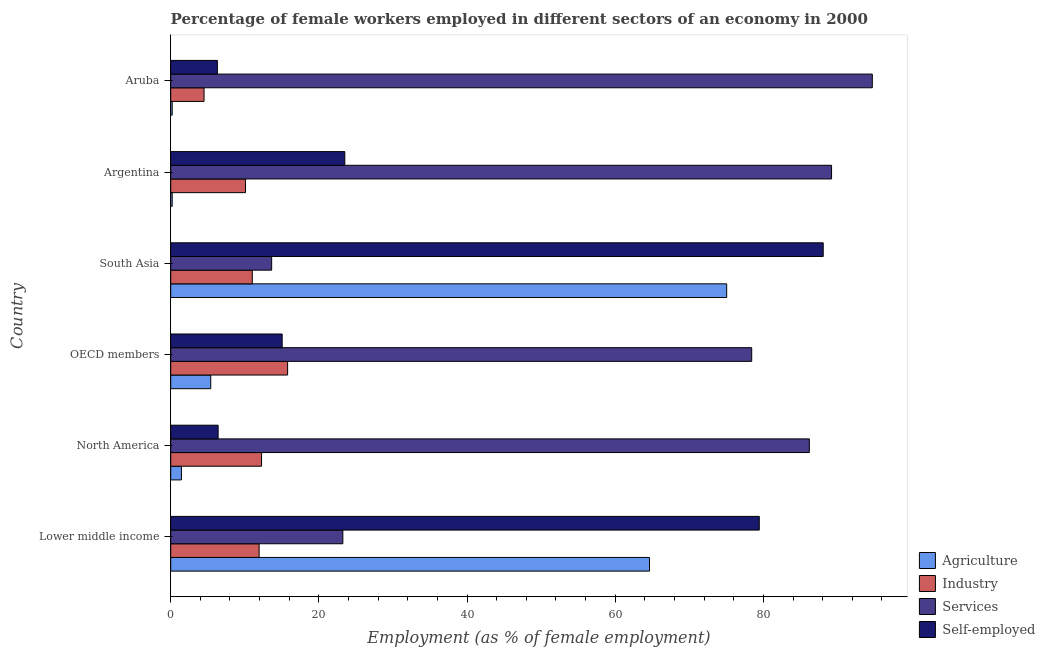How many different coloured bars are there?
Offer a very short reply. 4. Are the number of bars per tick equal to the number of legend labels?
Keep it short and to the point. Yes. Are the number of bars on each tick of the Y-axis equal?
Give a very brief answer. Yes. What is the percentage of female workers in industry in Lower middle income?
Your answer should be very brief. 11.94. Across all countries, what is the maximum percentage of female workers in industry?
Give a very brief answer. 15.78. Across all countries, what is the minimum percentage of self employed female workers?
Provide a short and direct response. 6.3. In which country was the percentage of self employed female workers maximum?
Ensure brevity in your answer.  South Asia. In which country was the percentage of female workers in industry minimum?
Offer a very short reply. Aruba. What is the total percentage of female workers in services in the graph?
Give a very brief answer. 385.38. What is the difference between the percentage of female workers in industry in Aruba and that in North America?
Give a very brief answer. -7.76. What is the difference between the percentage of female workers in industry in South Asia and the percentage of female workers in services in North America?
Offer a very short reply. -75.19. What is the average percentage of female workers in industry per country?
Give a very brief answer. 10.93. What is the difference between the percentage of female workers in services and percentage of female workers in agriculture in South Asia?
Provide a short and direct response. -61.41. What is the ratio of the percentage of self employed female workers in Aruba to that in OECD members?
Offer a very short reply. 0.42. Is the difference between the percentage of self employed female workers in Aruba and OECD members greater than the difference between the percentage of female workers in agriculture in Aruba and OECD members?
Make the answer very short. No. What is the difference between the highest and the second highest percentage of female workers in industry?
Offer a very short reply. 3.52. What is the difference between the highest and the lowest percentage of female workers in services?
Your response must be concise. 81.07. What does the 4th bar from the top in Lower middle income represents?
Provide a short and direct response. Agriculture. What does the 1st bar from the bottom in OECD members represents?
Ensure brevity in your answer.  Agriculture. Is it the case that in every country, the sum of the percentage of female workers in agriculture and percentage of female workers in industry is greater than the percentage of female workers in services?
Your answer should be compact. No. How many bars are there?
Provide a short and direct response. 24. How many countries are there in the graph?
Ensure brevity in your answer.  6. What is the difference between two consecutive major ticks on the X-axis?
Offer a very short reply. 20. Are the values on the major ticks of X-axis written in scientific E-notation?
Provide a succinct answer. No. Does the graph contain any zero values?
Keep it short and to the point. No. How many legend labels are there?
Offer a very short reply. 4. What is the title of the graph?
Offer a very short reply. Percentage of female workers employed in different sectors of an economy in 2000. What is the label or title of the X-axis?
Your answer should be very brief. Employment (as % of female employment). What is the label or title of the Y-axis?
Offer a very short reply. Country. What is the Employment (as % of female employment) of Agriculture in Lower middle income?
Your answer should be compact. 64.63. What is the Employment (as % of female employment) of Industry in Lower middle income?
Your response must be concise. 11.94. What is the Employment (as % of female employment) of Services in Lower middle income?
Offer a very short reply. 23.24. What is the Employment (as % of female employment) in Self-employed in Lower middle income?
Your answer should be compact. 79.44. What is the Employment (as % of female employment) of Agriculture in North America?
Make the answer very short. 1.45. What is the Employment (as % of female employment) of Industry in North America?
Offer a terse response. 12.26. What is the Employment (as % of female employment) in Services in North America?
Keep it short and to the point. 86.2. What is the Employment (as % of female employment) of Self-employed in North America?
Your answer should be very brief. 6.4. What is the Employment (as % of female employment) of Agriculture in OECD members?
Your response must be concise. 5.4. What is the Employment (as % of female employment) of Industry in OECD members?
Keep it short and to the point. 15.78. What is the Employment (as % of female employment) of Services in OECD members?
Provide a succinct answer. 78.42. What is the Employment (as % of female employment) of Self-employed in OECD members?
Offer a very short reply. 15.05. What is the Employment (as % of female employment) of Agriculture in South Asia?
Offer a terse response. 75.04. What is the Employment (as % of female employment) of Industry in South Asia?
Your answer should be compact. 11.01. What is the Employment (as % of female employment) in Services in South Asia?
Ensure brevity in your answer.  13.63. What is the Employment (as % of female employment) in Self-employed in South Asia?
Your response must be concise. 88.07. What is the Employment (as % of female employment) of Agriculture in Argentina?
Keep it short and to the point. 0.2. What is the Employment (as % of female employment) of Industry in Argentina?
Your response must be concise. 10.1. What is the Employment (as % of female employment) in Services in Argentina?
Provide a short and direct response. 89.2. What is the Employment (as % of female employment) of Agriculture in Aruba?
Your answer should be compact. 0.2. What is the Employment (as % of female employment) in Industry in Aruba?
Provide a succinct answer. 4.5. What is the Employment (as % of female employment) in Services in Aruba?
Give a very brief answer. 94.7. What is the Employment (as % of female employment) in Self-employed in Aruba?
Ensure brevity in your answer.  6.3. Across all countries, what is the maximum Employment (as % of female employment) of Agriculture?
Your answer should be compact. 75.04. Across all countries, what is the maximum Employment (as % of female employment) in Industry?
Provide a succinct answer. 15.78. Across all countries, what is the maximum Employment (as % of female employment) in Services?
Your answer should be very brief. 94.7. Across all countries, what is the maximum Employment (as % of female employment) in Self-employed?
Give a very brief answer. 88.07. Across all countries, what is the minimum Employment (as % of female employment) of Agriculture?
Provide a short and direct response. 0.2. Across all countries, what is the minimum Employment (as % of female employment) of Services?
Provide a short and direct response. 13.63. Across all countries, what is the minimum Employment (as % of female employment) in Self-employed?
Make the answer very short. 6.3. What is the total Employment (as % of female employment) in Agriculture in the graph?
Your answer should be very brief. 146.92. What is the total Employment (as % of female employment) in Industry in the graph?
Ensure brevity in your answer.  65.59. What is the total Employment (as % of female employment) in Services in the graph?
Ensure brevity in your answer.  385.38. What is the total Employment (as % of female employment) of Self-employed in the graph?
Ensure brevity in your answer.  218.76. What is the difference between the Employment (as % of female employment) of Agriculture in Lower middle income and that in North America?
Your answer should be very brief. 63.18. What is the difference between the Employment (as % of female employment) of Industry in Lower middle income and that in North America?
Your answer should be compact. -0.33. What is the difference between the Employment (as % of female employment) in Services in Lower middle income and that in North America?
Your answer should be very brief. -62.96. What is the difference between the Employment (as % of female employment) in Self-employed in Lower middle income and that in North America?
Offer a terse response. 73.04. What is the difference between the Employment (as % of female employment) of Agriculture in Lower middle income and that in OECD members?
Provide a short and direct response. 59.22. What is the difference between the Employment (as % of female employment) in Industry in Lower middle income and that in OECD members?
Offer a terse response. -3.84. What is the difference between the Employment (as % of female employment) of Services in Lower middle income and that in OECD members?
Give a very brief answer. -55.18. What is the difference between the Employment (as % of female employment) of Self-employed in Lower middle income and that in OECD members?
Your answer should be very brief. 64.4. What is the difference between the Employment (as % of female employment) in Agriculture in Lower middle income and that in South Asia?
Offer a terse response. -10.42. What is the difference between the Employment (as % of female employment) of Industry in Lower middle income and that in South Asia?
Your response must be concise. 0.92. What is the difference between the Employment (as % of female employment) in Services in Lower middle income and that in South Asia?
Offer a very short reply. 9.61. What is the difference between the Employment (as % of female employment) of Self-employed in Lower middle income and that in South Asia?
Provide a short and direct response. -8.63. What is the difference between the Employment (as % of female employment) in Agriculture in Lower middle income and that in Argentina?
Provide a succinct answer. 64.43. What is the difference between the Employment (as % of female employment) in Industry in Lower middle income and that in Argentina?
Your response must be concise. 1.84. What is the difference between the Employment (as % of female employment) in Services in Lower middle income and that in Argentina?
Provide a succinct answer. -65.96. What is the difference between the Employment (as % of female employment) in Self-employed in Lower middle income and that in Argentina?
Ensure brevity in your answer.  55.94. What is the difference between the Employment (as % of female employment) in Agriculture in Lower middle income and that in Aruba?
Keep it short and to the point. 64.43. What is the difference between the Employment (as % of female employment) of Industry in Lower middle income and that in Aruba?
Offer a very short reply. 7.44. What is the difference between the Employment (as % of female employment) of Services in Lower middle income and that in Aruba?
Your answer should be very brief. -71.46. What is the difference between the Employment (as % of female employment) of Self-employed in Lower middle income and that in Aruba?
Give a very brief answer. 73.14. What is the difference between the Employment (as % of female employment) of Agriculture in North America and that in OECD members?
Provide a short and direct response. -3.96. What is the difference between the Employment (as % of female employment) in Industry in North America and that in OECD members?
Ensure brevity in your answer.  -3.52. What is the difference between the Employment (as % of female employment) in Services in North America and that in OECD members?
Keep it short and to the point. 7.78. What is the difference between the Employment (as % of female employment) of Self-employed in North America and that in OECD members?
Give a very brief answer. -8.64. What is the difference between the Employment (as % of female employment) in Agriculture in North America and that in South Asia?
Ensure brevity in your answer.  -73.59. What is the difference between the Employment (as % of female employment) in Industry in North America and that in South Asia?
Provide a succinct answer. 1.25. What is the difference between the Employment (as % of female employment) of Services in North America and that in South Asia?
Your answer should be compact. 72.57. What is the difference between the Employment (as % of female employment) of Self-employed in North America and that in South Asia?
Offer a terse response. -81.67. What is the difference between the Employment (as % of female employment) in Agriculture in North America and that in Argentina?
Make the answer very short. 1.25. What is the difference between the Employment (as % of female employment) in Industry in North America and that in Argentina?
Offer a very short reply. 2.16. What is the difference between the Employment (as % of female employment) in Self-employed in North America and that in Argentina?
Offer a terse response. -17.1. What is the difference between the Employment (as % of female employment) in Agriculture in North America and that in Aruba?
Offer a very short reply. 1.25. What is the difference between the Employment (as % of female employment) in Industry in North America and that in Aruba?
Keep it short and to the point. 7.76. What is the difference between the Employment (as % of female employment) in Services in North America and that in Aruba?
Ensure brevity in your answer.  -8.5. What is the difference between the Employment (as % of female employment) of Self-employed in North America and that in Aruba?
Your answer should be very brief. 0.1. What is the difference between the Employment (as % of female employment) of Agriculture in OECD members and that in South Asia?
Your answer should be very brief. -69.64. What is the difference between the Employment (as % of female employment) in Industry in OECD members and that in South Asia?
Provide a succinct answer. 4.77. What is the difference between the Employment (as % of female employment) of Services in OECD members and that in South Asia?
Your answer should be very brief. 64.79. What is the difference between the Employment (as % of female employment) of Self-employed in OECD members and that in South Asia?
Provide a short and direct response. -73.03. What is the difference between the Employment (as % of female employment) in Agriculture in OECD members and that in Argentina?
Offer a terse response. 5.2. What is the difference between the Employment (as % of female employment) in Industry in OECD members and that in Argentina?
Ensure brevity in your answer.  5.68. What is the difference between the Employment (as % of female employment) of Services in OECD members and that in Argentina?
Keep it short and to the point. -10.78. What is the difference between the Employment (as % of female employment) in Self-employed in OECD members and that in Argentina?
Ensure brevity in your answer.  -8.45. What is the difference between the Employment (as % of female employment) in Agriculture in OECD members and that in Aruba?
Ensure brevity in your answer.  5.2. What is the difference between the Employment (as % of female employment) in Industry in OECD members and that in Aruba?
Offer a very short reply. 11.28. What is the difference between the Employment (as % of female employment) of Services in OECD members and that in Aruba?
Offer a terse response. -16.28. What is the difference between the Employment (as % of female employment) in Self-employed in OECD members and that in Aruba?
Your answer should be very brief. 8.75. What is the difference between the Employment (as % of female employment) in Agriculture in South Asia and that in Argentina?
Your answer should be compact. 74.84. What is the difference between the Employment (as % of female employment) of Industry in South Asia and that in Argentina?
Offer a very short reply. 0.91. What is the difference between the Employment (as % of female employment) in Services in South Asia and that in Argentina?
Keep it short and to the point. -75.57. What is the difference between the Employment (as % of female employment) in Self-employed in South Asia and that in Argentina?
Provide a short and direct response. 64.57. What is the difference between the Employment (as % of female employment) in Agriculture in South Asia and that in Aruba?
Provide a succinct answer. 74.84. What is the difference between the Employment (as % of female employment) of Industry in South Asia and that in Aruba?
Give a very brief answer. 6.51. What is the difference between the Employment (as % of female employment) of Services in South Asia and that in Aruba?
Make the answer very short. -81.07. What is the difference between the Employment (as % of female employment) of Self-employed in South Asia and that in Aruba?
Ensure brevity in your answer.  81.77. What is the difference between the Employment (as % of female employment) in Agriculture in Argentina and that in Aruba?
Offer a very short reply. 0. What is the difference between the Employment (as % of female employment) of Agriculture in Lower middle income and the Employment (as % of female employment) of Industry in North America?
Offer a very short reply. 52.37. What is the difference between the Employment (as % of female employment) in Agriculture in Lower middle income and the Employment (as % of female employment) in Services in North America?
Your response must be concise. -21.57. What is the difference between the Employment (as % of female employment) of Agriculture in Lower middle income and the Employment (as % of female employment) of Self-employed in North America?
Make the answer very short. 58.23. What is the difference between the Employment (as % of female employment) of Industry in Lower middle income and the Employment (as % of female employment) of Services in North America?
Your answer should be very brief. -74.26. What is the difference between the Employment (as % of female employment) in Industry in Lower middle income and the Employment (as % of female employment) in Self-employed in North America?
Ensure brevity in your answer.  5.53. What is the difference between the Employment (as % of female employment) in Services in Lower middle income and the Employment (as % of female employment) in Self-employed in North America?
Keep it short and to the point. 16.83. What is the difference between the Employment (as % of female employment) in Agriculture in Lower middle income and the Employment (as % of female employment) in Industry in OECD members?
Keep it short and to the point. 48.85. What is the difference between the Employment (as % of female employment) in Agriculture in Lower middle income and the Employment (as % of female employment) in Services in OECD members?
Provide a short and direct response. -13.79. What is the difference between the Employment (as % of female employment) in Agriculture in Lower middle income and the Employment (as % of female employment) in Self-employed in OECD members?
Your answer should be compact. 49.58. What is the difference between the Employment (as % of female employment) in Industry in Lower middle income and the Employment (as % of female employment) in Services in OECD members?
Give a very brief answer. -66.48. What is the difference between the Employment (as % of female employment) in Industry in Lower middle income and the Employment (as % of female employment) in Self-employed in OECD members?
Offer a terse response. -3.11. What is the difference between the Employment (as % of female employment) of Services in Lower middle income and the Employment (as % of female employment) of Self-employed in OECD members?
Ensure brevity in your answer.  8.19. What is the difference between the Employment (as % of female employment) in Agriculture in Lower middle income and the Employment (as % of female employment) in Industry in South Asia?
Give a very brief answer. 53.62. What is the difference between the Employment (as % of female employment) of Agriculture in Lower middle income and the Employment (as % of female employment) of Services in South Asia?
Your response must be concise. 51. What is the difference between the Employment (as % of female employment) of Agriculture in Lower middle income and the Employment (as % of female employment) of Self-employed in South Asia?
Provide a succinct answer. -23.45. What is the difference between the Employment (as % of female employment) of Industry in Lower middle income and the Employment (as % of female employment) of Services in South Asia?
Make the answer very short. -1.69. What is the difference between the Employment (as % of female employment) of Industry in Lower middle income and the Employment (as % of female employment) of Self-employed in South Asia?
Provide a short and direct response. -76.14. What is the difference between the Employment (as % of female employment) of Services in Lower middle income and the Employment (as % of female employment) of Self-employed in South Asia?
Your answer should be very brief. -64.84. What is the difference between the Employment (as % of female employment) in Agriculture in Lower middle income and the Employment (as % of female employment) in Industry in Argentina?
Give a very brief answer. 54.53. What is the difference between the Employment (as % of female employment) in Agriculture in Lower middle income and the Employment (as % of female employment) in Services in Argentina?
Provide a succinct answer. -24.57. What is the difference between the Employment (as % of female employment) in Agriculture in Lower middle income and the Employment (as % of female employment) in Self-employed in Argentina?
Give a very brief answer. 41.13. What is the difference between the Employment (as % of female employment) in Industry in Lower middle income and the Employment (as % of female employment) in Services in Argentina?
Your answer should be compact. -77.26. What is the difference between the Employment (as % of female employment) in Industry in Lower middle income and the Employment (as % of female employment) in Self-employed in Argentina?
Ensure brevity in your answer.  -11.56. What is the difference between the Employment (as % of female employment) of Services in Lower middle income and the Employment (as % of female employment) of Self-employed in Argentina?
Ensure brevity in your answer.  -0.26. What is the difference between the Employment (as % of female employment) of Agriculture in Lower middle income and the Employment (as % of female employment) of Industry in Aruba?
Your answer should be compact. 60.13. What is the difference between the Employment (as % of female employment) in Agriculture in Lower middle income and the Employment (as % of female employment) in Services in Aruba?
Give a very brief answer. -30.07. What is the difference between the Employment (as % of female employment) of Agriculture in Lower middle income and the Employment (as % of female employment) of Self-employed in Aruba?
Offer a very short reply. 58.33. What is the difference between the Employment (as % of female employment) in Industry in Lower middle income and the Employment (as % of female employment) in Services in Aruba?
Give a very brief answer. -82.76. What is the difference between the Employment (as % of female employment) of Industry in Lower middle income and the Employment (as % of female employment) of Self-employed in Aruba?
Your response must be concise. 5.64. What is the difference between the Employment (as % of female employment) in Services in Lower middle income and the Employment (as % of female employment) in Self-employed in Aruba?
Ensure brevity in your answer.  16.94. What is the difference between the Employment (as % of female employment) of Agriculture in North America and the Employment (as % of female employment) of Industry in OECD members?
Provide a short and direct response. -14.33. What is the difference between the Employment (as % of female employment) of Agriculture in North America and the Employment (as % of female employment) of Services in OECD members?
Make the answer very short. -76.97. What is the difference between the Employment (as % of female employment) in Agriculture in North America and the Employment (as % of female employment) in Self-employed in OECD members?
Your answer should be very brief. -13.6. What is the difference between the Employment (as % of female employment) in Industry in North America and the Employment (as % of female employment) in Services in OECD members?
Provide a succinct answer. -66.16. What is the difference between the Employment (as % of female employment) of Industry in North America and the Employment (as % of female employment) of Self-employed in OECD members?
Offer a terse response. -2.78. What is the difference between the Employment (as % of female employment) in Services in North America and the Employment (as % of female employment) in Self-employed in OECD members?
Provide a succinct answer. 71.15. What is the difference between the Employment (as % of female employment) of Agriculture in North America and the Employment (as % of female employment) of Industry in South Asia?
Keep it short and to the point. -9.56. What is the difference between the Employment (as % of female employment) of Agriculture in North America and the Employment (as % of female employment) of Services in South Asia?
Offer a terse response. -12.18. What is the difference between the Employment (as % of female employment) in Agriculture in North America and the Employment (as % of female employment) in Self-employed in South Asia?
Give a very brief answer. -86.62. What is the difference between the Employment (as % of female employment) in Industry in North America and the Employment (as % of female employment) in Services in South Asia?
Your answer should be compact. -1.37. What is the difference between the Employment (as % of female employment) in Industry in North America and the Employment (as % of female employment) in Self-employed in South Asia?
Your answer should be compact. -75.81. What is the difference between the Employment (as % of female employment) in Services in North America and the Employment (as % of female employment) in Self-employed in South Asia?
Give a very brief answer. -1.87. What is the difference between the Employment (as % of female employment) of Agriculture in North America and the Employment (as % of female employment) of Industry in Argentina?
Your response must be concise. -8.65. What is the difference between the Employment (as % of female employment) in Agriculture in North America and the Employment (as % of female employment) in Services in Argentina?
Offer a terse response. -87.75. What is the difference between the Employment (as % of female employment) in Agriculture in North America and the Employment (as % of female employment) in Self-employed in Argentina?
Offer a very short reply. -22.05. What is the difference between the Employment (as % of female employment) in Industry in North America and the Employment (as % of female employment) in Services in Argentina?
Your answer should be very brief. -76.94. What is the difference between the Employment (as % of female employment) of Industry in North America and the Employment (as % of female employment) of Self-employed in Argentina?
Provide a short and direct response. -11.24. What is the difference between the Employment (as % of female employment) of Services in North America and the Employment (as % of female employment) of Self-employed in Argentina?
Your answer should be compact. 62.7. What is the difference between the Employment (as % of female employment) in Agriculture in North America and the Employment (as % of female employment) in Industry in Aruba?
Make the answer very short. -3.05. What is the difference between the Employment (as % of female employment) of Agriculture in North America and the Employment (as % of female employment) of Services in Aruba?
Offer a very short reply. -93.25. What is the difference between the Employment (as % of female employment) of Agriculture in North America and the Employment (as % of female employment) of Self-employed in Aruba?
Your answer should be compact. -4.85. What is the difference between the Employment (as % of female employment) of Industry in North America and the Employment (as % of female employment) of Services in Aruba?
Keep it short and to the point. -82.44. What is the difference between the Employment (as % of female employment) in Industry in North America and the Employment (as % of female employment) in Self-employed in Aruba?
Make the answer very short. 5.96. What is the difference between the Employment (as % of female employment) in Services in North America and the Employment (as % of female employment) in Self-employed in Aruba?
Your answer should be very brief. 79.9. What is the difference between the Employment (as % of female employment) in Agriculture in OECD members and the Employment (as % of female employment) in Industry in South Asia?
Ensure brevity in your answer.  -5.61. What is the difference between the Employment (as % of female employment) in Agriculture in OECD members and the Employment (as % of female employment) in Services in South Asia?
Provide a succinct answer. -8.22. What is the difference between the Employment (as % of female employment) in Agriculture in OECD members and the Employment (as % of female employment) in Self-employed in South Asia?
Keep it short and to the point. -82.67. What is the difference between the Employment (as % of female employment) in Industry in OECD members and the Employment (as % of female employment) in Services in South Asia?
Make the answer very short. 2.15. What is the difference between the Employment (as % of female employment) of Industry in OECD members and the Employment (as % of female employment) of Self-employed in South Asia?
Offer a terse response. -72.29. What is the difference between the Employment (as % of female employment) of Services in OECD members and the Employment (as % of female employment) of Self-employed in South Asia?
Provide a succinct answer. -9.65. What is the difference between the Employment (as % of female employment) of Agriculture in OECD members and the Employment (as % of female employment) of Industry in Argentina?
Your response must be concise. -4.7. What is the difference between the Employment (as % of female employment) in Agriculture in OECD members and the Employment (as % of female employment) in Services in Argentina?
Make the answer very short. -83.8. What is the difference between the Employment (as % of female employment) in Agriculture in OECD members and the Employment (as % of female employment) in Self-employed in Argentina?
Ensure brevity in your answer.  -18.1. What is the difference between the Employment (as % of female employment) in Industry in OECD members and the Employment (as % of female employment) in Services in Argentina?
Provide a succinct answer. -73.42. What is the difference between the Employment (as % of female employment) in Industry in OECD members and the Employment (as % of female employment) in Self-employed in Argentina?
Your answer should be compact. -7.72. What is the difference between the Employment (as % of female employment) of Services in OECD members and the Employment (as % of female employment) of Self-employed in Argentina?
Your response must be concise. 54.92. What is the difference between the Employment (as % of female employment) in Agriculture in OECD members and the Employment (as % of female employment) in Industry in Aruba?
Your response must be concise. 0.9. What is the difference between the Employment (as % of female employment) of Agriculture in OECD members and the Employment (as % of female employment) of Services in Aruba?
Your response must be concise. -89.3. What is the difference between the Employment (as % of female employment) of Agriculture in OECD members and the Employment (as % of female employment) of Self-employed in Aruba?
Make the answer very short. -0.9. What is the difference between the Employment (as % of female employment) in Industry in OECD members and the Employment (as % of female employment) in Services in Aruba?
Provide a short and direct response. -78.92. What is the difference between the Employment (as % of female employment) in Industry in OECD members and the Employment (as % of female employment) in Self-employed in Aruba?
Provide a short and direct response. 9.48. What is the difference between the Employment (as % of female employment) of Services in OECD members and the Employment (as % of female employment) of Self-employed in Aruba?
Provide a short and direct response. 72.12. What is the difference between the Employment (as % of female employment) of Agriculture in South Asia and the Employment (as % of female employment) of Industry in Argentina?
Offer a very short reply. 64.94. What is the difference between the Employment (as % of female employment) in Agriculture in South Asia and the Employment (as % of female employment) in Services in Argentina?
Give a very brief answer. -14.16. What is the difference between the Employment (as % of female employment) in Agriculture in South Asia and the Employment (as % of female employment) in Self-employed in Argentina?
Give a very brief answer. 51.54. What is the difference between the Employment (as % of female employment) of Industry in South Asia and the Employment (as % of female employment) of Services in Argentina?
Your response must be concise. -78.19. What is the difference between the Employment (as % of female employment) of Industry in South Asia and the Employment (as % of female employment) of Self-employed in Argentina?
Provide a short and direct response. -12.49. What is the difference between the Employment (as % of female employment) in Services in South Asia and the Employment (as % of female employment) in Self-employed in Argentina?
Offer a very short reply. -9.87. What is the difference between the Employment (as % of female employment) of Agriculture in South Asia and the Employment (as % of female employment) of Industry in Aruba?
Offer a very short reply. 70.54. What is the difference between the Employment (as % of female employment) in Agriculture in South Asia and the Employment (as % of female employment) in Services in Aruba?
Your answer should be very brief. -19.66. What is the difference between the Employment (as % of female employment) of Agriculture in South Asia and the Employment (as % of female employment) of Self-employed in Aruba?
Make the answer very short. 68.74. What is the difference between the Employment (as % of female employment) in Industry in South Asia and the Employment (as % of female employment) in Services in Aruba?
Keep it short and to the point. -83.69. What is the difference between the Employment (as % of female employment) of Industry in South Asia and the Employment (as % of female employment) of Self-employed in Aruba?
Make the answer very short. 4.71. What is the difference between the Employment (as % of female employment) of Services in South Asia and the Employment (as % of female employment) of Self-employed in Aruba?
Provide a succinct answer. 7.33. What is the difference between the Employment (as % of female employment) in Agriculture in Argentina and the Employment (as % of female employment) in Services in Aruba?
Provide a succinct answer. -94.5. What is the difference between the Employment (as % of female employment) in Industry in Argentina and the Employment (as % of female employment) in Services in Aruba?
Your answer should be compact. -84.6. What is the difference between the Employment (as % of female employment) of Industry in Argentina and the Employment (as % of female employment) of Self-employed in Aruba?
Make the answer very short. 3.8. What is the difference between the Employment (as % of female employment) of Services in Argentina and the Employment (as % of female employment) of Self-employed in Aruba?
Provide a succinct answer. 82.9. What is the average Employment (as % of female employment) in Agriculture per country?
Ensure brevity in your answer.  24.49. What is the average Employment (as % of female employment) of Industry per country?
Ensure brevity in your answer.  10.93. What is the average Employment (as % of female employment) in Services per country?
Give a very brief answer. 64.23. What is the average Employment (as % of female employment) in Self-employed per country?
Keep it short and to the point. 36.46. What is the difference between the Employment (as % of female employment) of Agriculture and Employment (as % of female employment) of Industry in Lower middle income?
Ensure brevity in your answer.  52.69. What is the difference between the Employment (as % of female employment) in Agriculture and Employment (as % of female employment) in Services in Lower middle income?
Provide a succinct answer. 41.39. What is the difference between the Employment (as % of female employment) in Agriculture and Employment (as % of female employment) in Self-employed in Lower middle income?
Offer a very short reply. -14.82. What is the difference between the Employment (as % of female employment) of Industry and Employment (as % of female employment) of Services in Lower middle income?
Your response must be concise. -11.3. What is the difference between the Employment (as % of female employment) in Industry and Employment (as % of female employment) in Self-employed in Lower middle income?
Provide a succinct answer. -67.51. What is the difference between the Employment (as % of female employment) of Services and Employment (as % of female employment) of Self-employed in Lower middle income?
Your response must be concise. -56.21. What is the difference between the Employment (as % of female employment) in Agriculture and Employment (as % of female employment) in Industry in North America?
Provide a succinct answer. -10.81. What is the difference between the Employment (as % of female employment) in Agriculture and Employment (as % of female employment) in Services in North America?
Offer a very short reply. -84.75. What is the difference between the Employment (as % of female employment) in Agriculture and Employment (as % of female employment) in Self-employed in North America?
Offer a very short reply. -4.95. What is the difference between the Employment (as % of female employment) of Industry and Employment (as % of female employment) of Services in North America?
Provide a succinct answer. -73.94. What is the difference between the Employment (as % of female employment) in Industry and Employment (as % of female employment) in Self-employed in North America?
Make the answer very short. 5.86. What is the difference between the Employment (as % of female employment) in Services and Employment (as % of female employment) in Self-employed in North America?
Provide a short and direct response. 79.8. What is the difference between the Employment (as % of female employment) in Agriculture and Employment (as % of female employment) in Industry in OECD members?
Your answer should be very brief. -10.37. What is the difference between the Employment (as % of female employment) of Agriculture and Employment (as % of female employment) of Services in OECD members?
Your answer should be compact. -73.01. What is the difference between the Employment (as % of female employment) in Agriculture and Employment (as % of female employment) in Self-employed in OECD members?
Your response must be concise. -9.64. What is the difference between the Employment (as % of female employment) of Industry and Employment (as % of female employment) of Services in OECD members?
Ensure brevity in your answer.  -62.64. What is the difference between the Employment (as % of female employment) of Industry and Employment (as % of female employment) of Self-employed in OECD members?
Offer a very short reply. 0.73. What is the difference between the Employment (as % of female employment) of Services and Employment (as % of female employment) of Self-employed in OECD members?
Provide a succinct answer. 63.37. What is the difference between the Employment (as % of female employment) in Agriculture and Employment (as % of female employment) in Industry in South Asia?
Your response must be concise. 64.03. What is the difference between the Employment (as % of female employment) of Agriculture and Employment (as % of female employment) of Services in South Asia?
Give a very brief answer. 61.42. What is the difference between the Employment (as % of female employment) of Agriculture and Employment (as % of female employment) of Self-employed in South Asia?
Provide a succinct answer. -13.03. What is the difference between the Employment (as % of female employment) in Industry and Employment (as % of female employment) in Services in South Asia?
Offer a terse response. -2.62. What is the difference between the Employment (as % of female employment) in Industry and Employment (as % of female employment) in Self-employed in South Asia?
Ensure brevity in your answer.  -77.06. What is the difference between the Employment (as % of female employment) of Services and Employment (as % of female employment) of Self-employed in South Asia?
Give a very brief answer. -74.45. What is the difference between the Employment (as % of female employment) of Agriculture and Employment (as % of female employment) of Services in Argentina?
Offer a very short reply. -89. What is the difference between the Employment (as % of female employment) in Agriculture and Employment (as % of female employment) in Self-employed in Argentina?
Make the answer very short. -23.3. What is the difference between the Employment (as % of female employment) in Industry and Employment (as % of female employment) in Services in Argentina?
Your response must be concise. -79.1. What is the difference between the Employment (as % of female employment) of Industry and Employment (as % of female employment) of Self-employed in Argentina?
Your answer should be compact. -13.4. What is the difference between the Employment (as % of female employment) of Services and Employment (as % of female employment) of Self-employed in Argentina?
Offer a terse response. 65.7. What is the difference between the Employment (as % of female employment) in Agriculture and Employment (as % of female employment) in Services in Aruba?
Offer a very short reply. -94.5. What is the difference between the Employment (as % of female employment) of Agriculture and Employment (as % of female employment) of Self-employed in Aruba?
Make the answer very short. -6.1. What is the difference between the Employment (as % of female employment) of Industry and Employment (as % of female employment) of Services in Aruba?
Ensure brevity in your answer.  -90.2. What is the difference between the Employment (as % of female employment) in Industry and Employment (as % of female employment) in Self-employed in Aruba?
Your response must be concise. -1.8. What is the difference between the Employment (as % of female employment) of Services and Employment (as % of female employment) of Self-employed in Aruba?
Give a very brief answer. 88.4. What is the ratio of the Employment (as % of female employment) of Agriculture in Lower middle income to that in North America?
Provide a short and direct response. 44.61. What is the ratio of the Employment (as % of female employment) of Industry in Lower middle income to that in North America?
Make the answer very short. 0.97. What is the ratio of the Employment (as % of female employment) of Services in Lower middle income to that in North America?
Offer a very short reply. 0.27. What is the ratio of the Employment (as % of female employment) of Self-employed in Lower middle income to that in North America?
Keep it short and to the point. 12.41. What is the ratio of the Employment (as % of female employment) in Agriculture in Lower middle income to that in OECD members?
Your response must be concise. 11.96. What is the ratio of the Employment (as % of female employment) in Industry in Lower middle income to that in OECD members?
Your answer should be very brief. 0.76. What is the ratio of the Employment (as % of female employment) of Services in Lower middle income to that in OECD members?
Your response must be concise. 0.3. What is the ratio of the Employment (as % of female employment) of Self-employed in Lower middle income to that in OECD members?
Give a very brief answer. 5.28. What is the ratio of the Employment (as % of female employment) in Agriculture in Lower middle income to that in South Asia?
Your response must be concise. 0.86. What is the ratio of the Employment (as % of female employment) in Industry in Lower middle income to that in South Asia?
Provide a succinct answer. 1.08. What is the ratio of the Employment (as % of female employment) of Services in Lower middle income to that in South Asia?
Ensure brevity in your answer.  1.71. What is the ratio of the Employment (as % of female employment) in Self-employed in Lower middle income to that in South Asia?
Ensure brevity in your answer.  0.9. What is the ratio of the Employment (as % of female employment) of Agriculture in Lower middle income to that in Argentina?
Your answer should be compact. 323.13. What is the ratio of the Employment (as % of female employment) in Industry in Lower middle income to that in Argentina?
Your response must be concise. 1.18. What is the ratio of the Employment (as % of female employment) of Services in Lower middle income to that in Argentina?
Provide a short and direct response. 0.26. What is the ratio of the Employment (as % of female employment) of Self-employed in Lower middle income to that in Argentina?
Keep it short and to the point. 3.38. What is the ratio of the Employment (as % of female employment) in Agriculture in Lower middle income to that in Aruba?
Provide a short and direct response. 323.13. What is the ratio of the Employment (as % of female employment) in Industry in Lower middle income to that in Aruba?
Provide a succinct answer. 2.65. What is the ratio of the Employment (as % of female employment) in Services in Lower middle income to that in Aruba?
Your answer should be compact. 0.25. What is the ratio of the Employment (as % of female employment) of Self-employed in Lower middle income to that in Aruba?
Ensure brevity in your answer.  12.61. What is the ratio of the Employment (as % of female employment) in Agriculture in North America to that in OECD members?
Your answer should be compact. 0.27. What is the ratio of the Employment (as % of female employment) in Industry in North America to that in OECD members?
Your answer should be compact. 0.78. What is the ratio of the Employment (as % of female employment) of Services in North America to that in OECD members?
Offer a very short reply. 1.1. What is the ratio of the Employment (as % of female employment) of Self-employed in North America to that in OECD members?
Ensure brevity in your answer.  0.43. What is the ratio of the Employment (as % of female employment) in Agriculture in North America to that in South Asia?
Ensure brevity in your answer.  0.02. What is the ratio of the Employment (as % of female employment) of Industry in North America to that in South Asia?
Keep it short and to the point. 1.11. What is the ratio of the Employment (as % of female employment) in Services in North America to that in South Asia?
Your response must be concise. 6.33. What is the ratio of the Employment (as % of female employment) of Self-employed in North America to that in South Asia?
Give a very brief answer. 0.07. What is the ratio of the Employment (as % of female employment) in Agriculture in North America to that in Argentina?
Make the answer very short. 7.24. What is the ratio of the Employment (as % of female employment) in Industry in North America to that in Argentina?
Offer a terse response. 1.21. What is the ratio of the Employment (as % of female employment) of Services in North America to that in Argentina?
Keep it short and to the point. 0.97. What is the ratio of the Employment (as % of female employment) of Self-employed in North America to that in Argentina?
Make the answer very short. 0.27. What is the ratio of the Employment (as % of female employment) in Agriculture in North America to that in Aruba?
Your answer should be compact. 7.24. What is the ratio of the Employment (as % of female employment) in Industry in North America to that in Aruba?
Ensure brevity in your answer.  2.72. What is the ratio of the Employment (as % of female employment) in Services in North America to that in Aruba?
Provide a short and direct response. 0.91. What is the ratio of the Employment (as % of female employment) of Self-employed in North America to that in Aruba?
Your answer should be very brief. 1.02. What is the ratio of the Employment (as % of female employment) in Agriculture in OECD members to that in South Asia?
Offer a terse response. 0.07. What is the ratio of the Employment (as % of female employment) of Industry in OECD members to that in South Asia?
Ensure brevity in your answer.  1.43. What is the ratio of the Employment (as % of female employment) in Services in OECD members to that in South Asia?
Offer a very short reply. 5.75. What is the ratio of the Employment (as % of female employment) of Self-employed in OECD members to that in South Asia?
Provide a succinct answer. 0.17. What is the ratio of the Employment (as % of female employment) of Agriculture in OECD members to that in Argentina?
Offer a terse response. 27.02. What is the ratio of the Employment (as % of female employment) of Industry in OECD members to that in Argentina?
Give a very brief answer. 1.56. What is the ratio of the Employment (as % of female employment) in Services in OECD members to that in Argentina?
Make the answer very short. 0.88. What is the ratio of the Employment (as % of female employment) of Self-employed in OECD members to that in Argentina?
Provide a short and direct response. 0.64. What is the ratio of the Employment (as % of female employment) of Agriculture in OECD members to that in Aruba?
Keep it short and to the point. 27.02. What is the ratio of the Employment (as % of female employment) of Industry in OECD members to that in Aruba?
Your response must be concise. 3.51. What is the ratio of the Employment (as % of female employment) in Services in OECD members to that in Aruba?
Make the answer very short. 0.83. What is the ratio of the Employment (as % of female employment) of Self-employed in OECD members to that in Aruba?
Give a very brief answer. 2.39. What is the ratio of the Employment (as % of female employment) of Agriculture in South Asia to that in Argentina?
Make the answer very short. 375.21. What is the ratio of the Employment (as % of female employment) in Industry in South Asia to that in Argentina?
Keep it short and to the point. 1.09. What is the ratio of the Employment (as % of female employment) in Services in South Asia to that in Argentina?
Make the answer very short. 0.15. What is the ratio of the Employment (as % of female employment) in Self-employed in South Asia to that in Argentina?
Your answer should be compact. 3.75. What is the ratio of the Employment (as % of female employment) in Agriculture in South Asia to that in Aruba?
Offer a terse response. 375.21. What is the ratio of the Employment (as % of female employment) in Industry in South Asia to that in Aruba?
Give a very brief answer. 2.45. What is the ratio of the Employment (as % of female employment) in Services in South Asia to that in Aruba?
Ensure brevity in your answer.  0.14. What is the ratio of the Employment (as % of female employment) of Self-employed in South Asia to that in Aruba?
Ensure brevity in your answer.  13.98. What is the ratio of the Employment (as % of female employment) in Agriculture in Argentina to that in Aruba?
Make the answer very short. 1. What is the ratio of the Employment (as % of female employment) in Industry in Argentina to that in Aruba?
Offer a very short reply. 2.24. What is the ratio of the Employment (as % of female employment) of Services in Argentina to that in Aruba?
Make the answer very short. 0.94. What is the ratio of the Employment (as % of female employment) of Self-employed in Argentina to that in Aruba?
Your answer should be compact. 3.73. What is the difference between the highest and the second highest Employment (as % of female employment) in Agriculture?
Your answer should be compact. 10.42. What is the difference between the highest and the second highest Employment (as % of female employment) of Industry?
Provide a short and direct response. 3.52. What is the difference between the highest and the second highest Employment (as % of female employment) in Self-employed?
Ensure brevity in your answer.  8.63. What is the difference between the highest and the lowest Employment (as % of female employment) of Agriculture?
Your answer should be very brief. 74.84. What is the difference between the highest and the lowest Employment (as % of female employment) in Industry?
Give a very brief answer. 11.28. What is the difference between the highest and the lowest Employment (as % of female employment) of Services?
Offer a terse response. 81.07. What is the difference between the highest and the lowest Employment (as % of female employment) of Self-employed?
Ensure brevity in your answer.  81.77. 